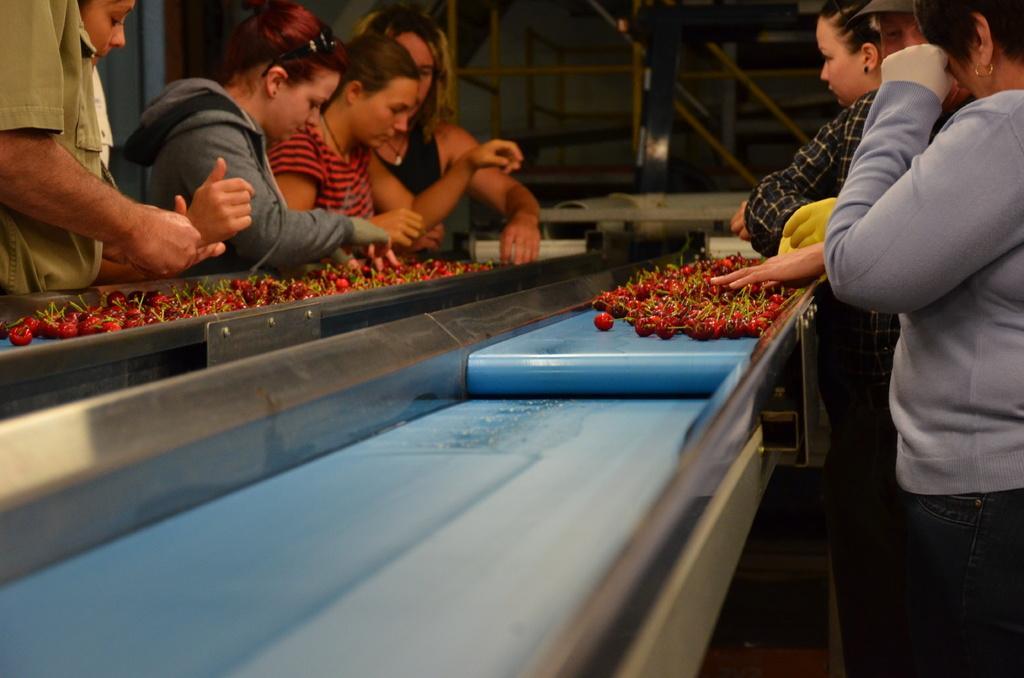Describe this image in one or two sentences. In this image we can see strawberries placed on the processing belt and there are people. In the background there are rods. 